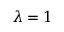<formula> <loc_0><loc_0><loc_500><loc_500>\lambda = 1</formula> 